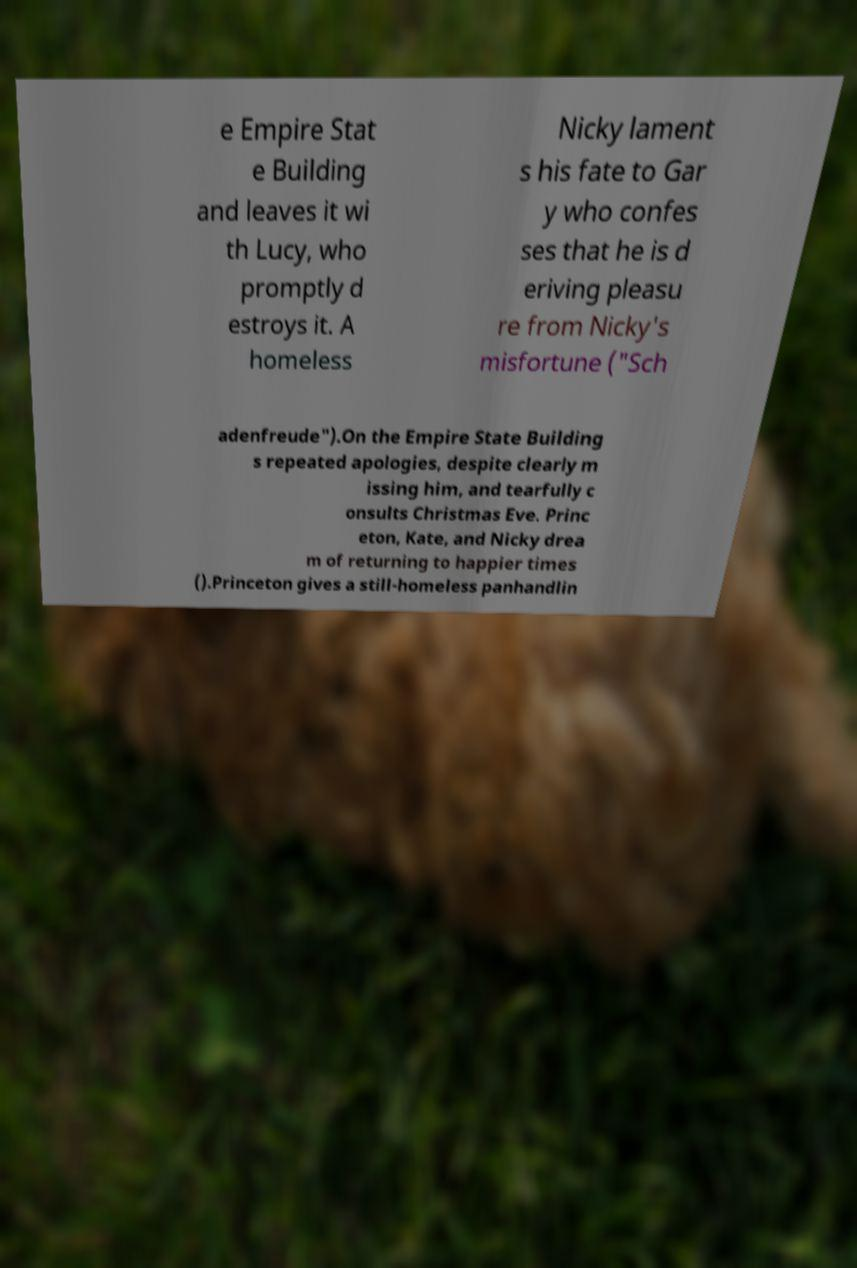Could you extract and type out the text from this image? e Empire Stat e Building and leaves it wi th Lucy, who promptly d estroys it. A homeless Nicky lament s his fate to Gar y who confes ses that he is d eriving pleasu re from Nicky's misfortune ("Sch adenfreude").On the Empire State Building s repeated apologies, despite clearly m issing him, and tearfully c onsults Christmas Eve. Princ eton, Kate, and Nicky drea m of returning to happier times ().Princeton gives a still-homeless panhandlin 